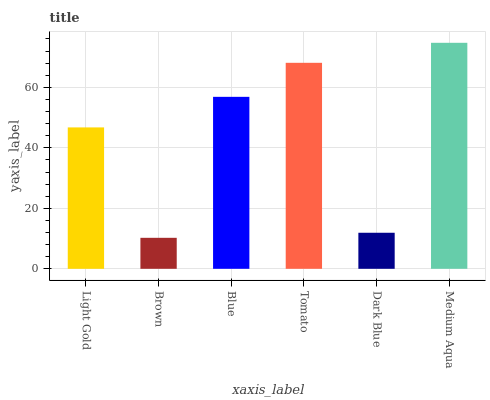Is Brown the minimum?
Answer yes or no. Yes. Is Medium Aqua the maximum?
Answer yes or no. Yes. Is Blue the minimum?
Answer yes or no. No. Is Blue the maximum?
Answer yes or no. No. Is Blue greater than Brown?
Answer yes or no. Yes. Is Brown less than Blue?
Answer yes or no. Yes. Is Brown greater than Blue?
Answer yes or no. No. Is Blue less than Brown?
Answer yes or no. No. Is Blue the high median?
Answer yes or no. Yes. Is Light Gold the low median?
Answer yes or no. Yes. Is Dark Blue the high median?
Answer yes or no. No. Is Blue the low median?
Answer yes or no. No. 